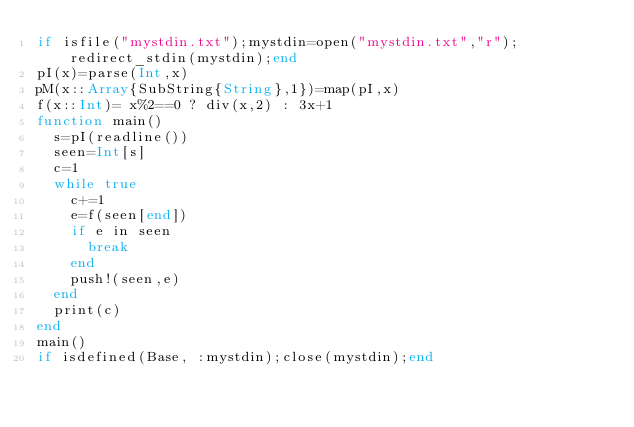Convert code to text. <code><loc_0><loc_0><loc_500><loc_500><_Julia_>if isfile("mystdin.txt");mystdin=open("mystdin.txt","r");redirect_stdin(mystdin);end
pI(x)=parse(Int,x)
pM(x::Array{SubString{String},1})=map(pI,x)
f(x::Int)= x%2==0 ? div(x,2) : 3x+1
function main()
  s=pI(readline())
  seen=Int[s]
  c=1
  while true
    c+=1
    e=f(seen[end])
    if e in seen
      break
    end
    push!(seen,e)
  end
  print(c)
end
main()
if isdefined(Base, :mystdin);close(mystdin);end
</code> 